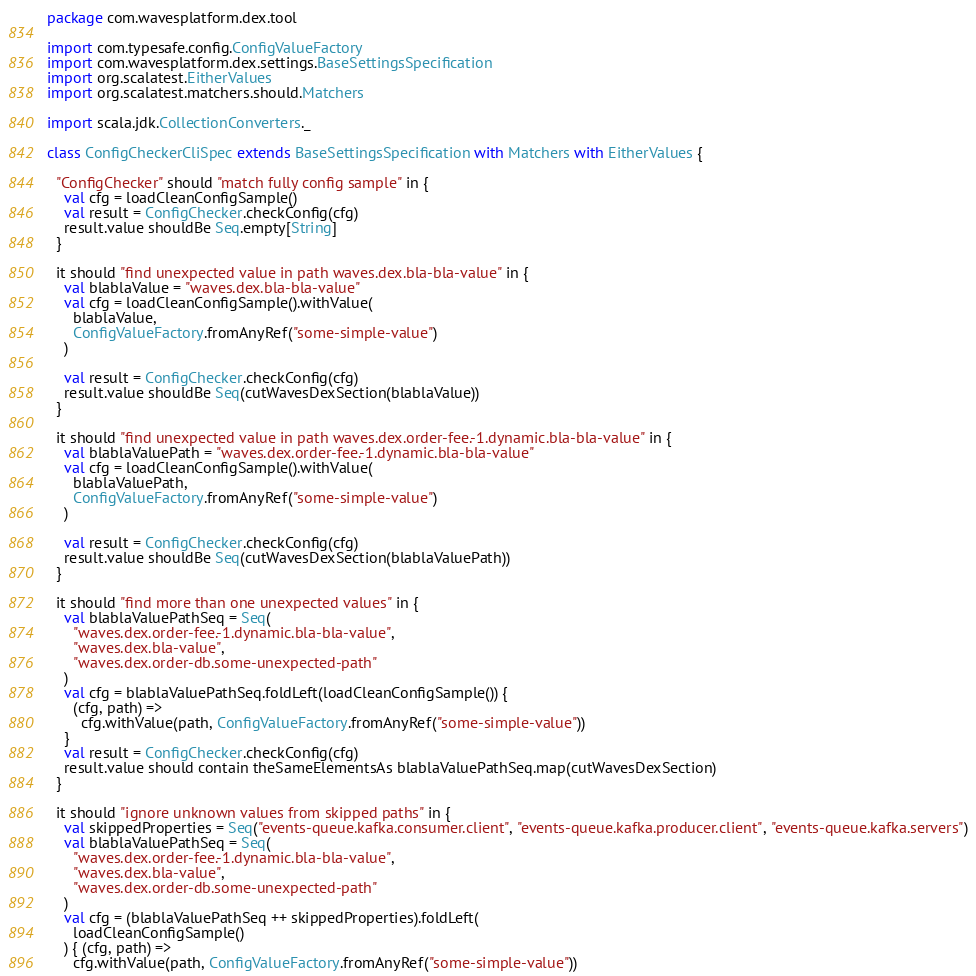<code> <loc_0><loc_0><loc_500><loc_500><_Scala_>package com.wavesplatform.dex.tool

import com.typesafe.config.ConfigValueFactory
import com.wavesplatform.dex.settings.BaseSettingsSpecification
import org.scalatest.EitherValues
import org.scalatest.matchers.should.Matchers

import scala.jdk.CollectionConverters._

class ConfigCheckerCliSpec extends BaseSettingsSpecification with Matchers with EitherValues {

  "ConfigChecker" should "match fully config sample" in {
    val cfg = loadCleanConfigSample()
    val result = ConfigChecker.checkConfig(cfg)
    result.value shouldBe Seq.empty[String]
  }

  it should "find unexpected value in path waves.dex.bla-bla-value" in {
    val blablaValue = "waves.dex.bla-bla-value"
    val cfg = loadCleanConfigSample().withValue(
      blablaValue,
      ConfigValueFactory.fromAnyRef("some-simple-value")
    )

    val result = ConfigChecker.checkConfig(cfg)
    result.value shouldBe Seq(cutWavesDexSection(blablaValue))
  }

  it should "find unexpected value in path waves.dex.order-fee.-1.dynamic.bla-bla-value" in {
    val blablaValuePath = "waves.dex.order-fee.-1.dynamic.bla-bla-value"
    val cfg = loadCleanConfigSample().withValue(
      blablaValuePath,
      ConfigValueFactory.fromAnyRef("some-simple-value")
    )

    val result = ConfigChecker.checkConfig(cfg)
    result.value shouldBe Seq(cutWavesDexSection(blablaValuePath))
  }

  it should "find more than one unexpected values" in {
    val blablaValuePathSeq = Seq(
      "waves.dex.order-fee.-1.dynamic.bla-bla-value",
      "waves.dex.bla-value",
      "waves.dex.order-db.some-unexpected-path"
    )
    val cfg = blablaValuePathSeq.foldLeft(loadCleanConfigSample()) {
      (cfg, path) =>
        cfg.withValue(path, ConfigValueFactory.fromAnyRef("some-simple-value"))
    }
    val result = ConfigChecker.checkConfig(cfg)
    result.value should contain theSameElementsAs blablaValuePathSeq.map(cutWavesDexSection)
  }

  it should "ignore unknown values from skipped paths" in {
    val skippedProperties = Seq("events-queue.kafka.consumer.client", "events-queue.kafka.producer.client", "events-queue.kafka.servers")
    val blablaValuePathSeq = Seq(
      "waves.dex.order-fee.-1.dynamic.bla-bla-value",
      "waves.dex.bla-value",
      "waves.dex.order-db.some-unexpected-path"
    )
    val cfg = (blablaValuePathSeq ++ skippedProperties).foldLeft(
      loadCleanConfigSample()
    ) { (cfg, path) =>
      cfg.withValue(path, ConfigValueFactory.fromAnyRef("some-simple-value"))</code> 